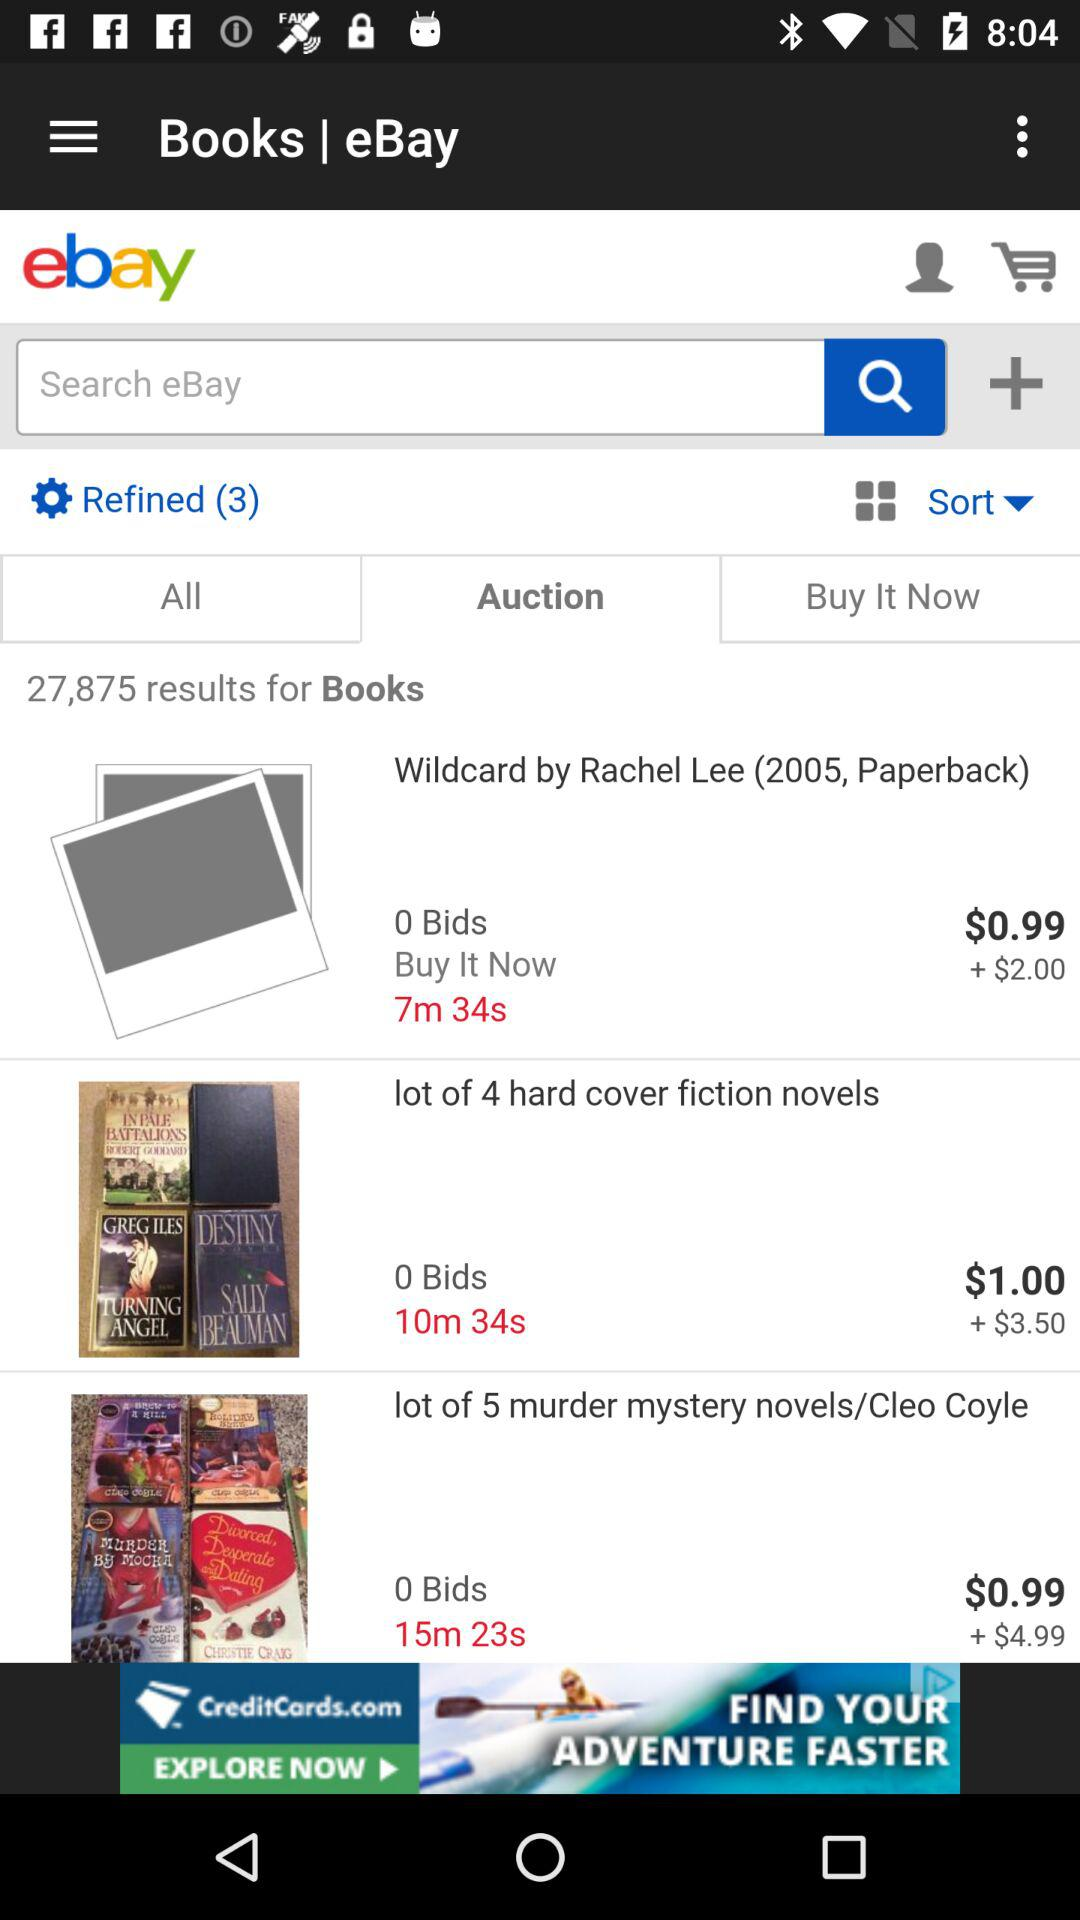What's the total number of results for books? The total number of results for books is 27,875. 